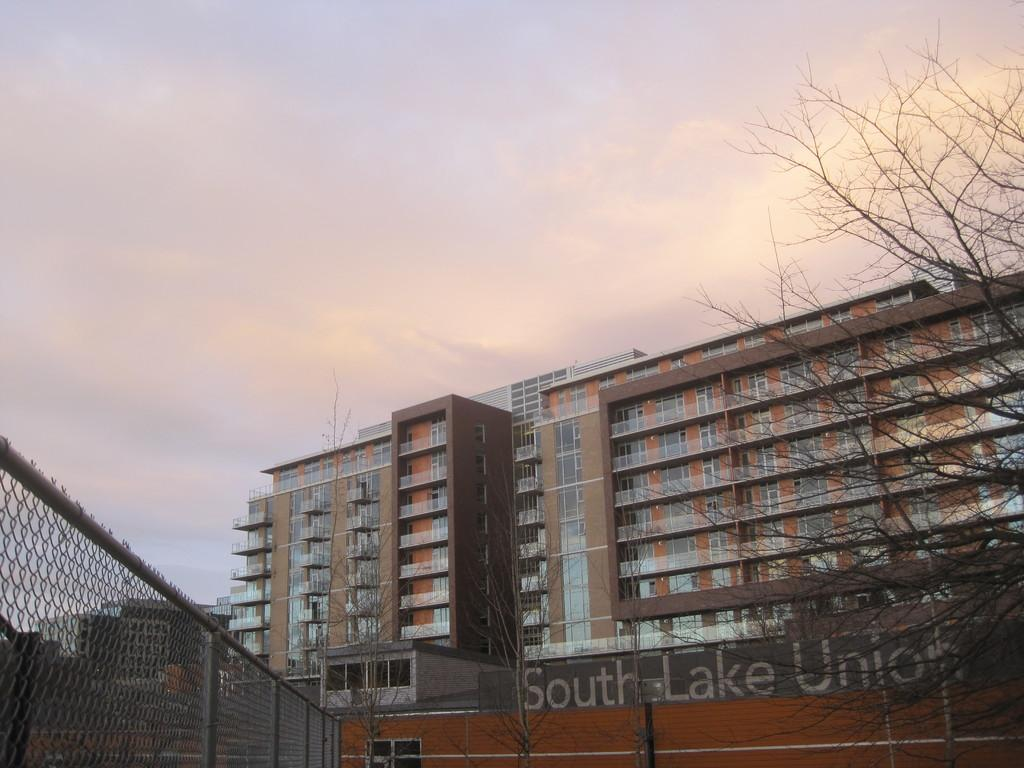What is the color of the building in the image? The building in the image is brown. What type of windows does the building have? The building has glass windows. What can be seen on the left side of the building? There is a fencing grill on the left side of the building. What is present in the right corner of the image? There is a dry tree in the right corner of the image. What time of day is it in the image, given the presence of giants? There are no giants present in the image, so we cannot determine the time of day based on their presence. 